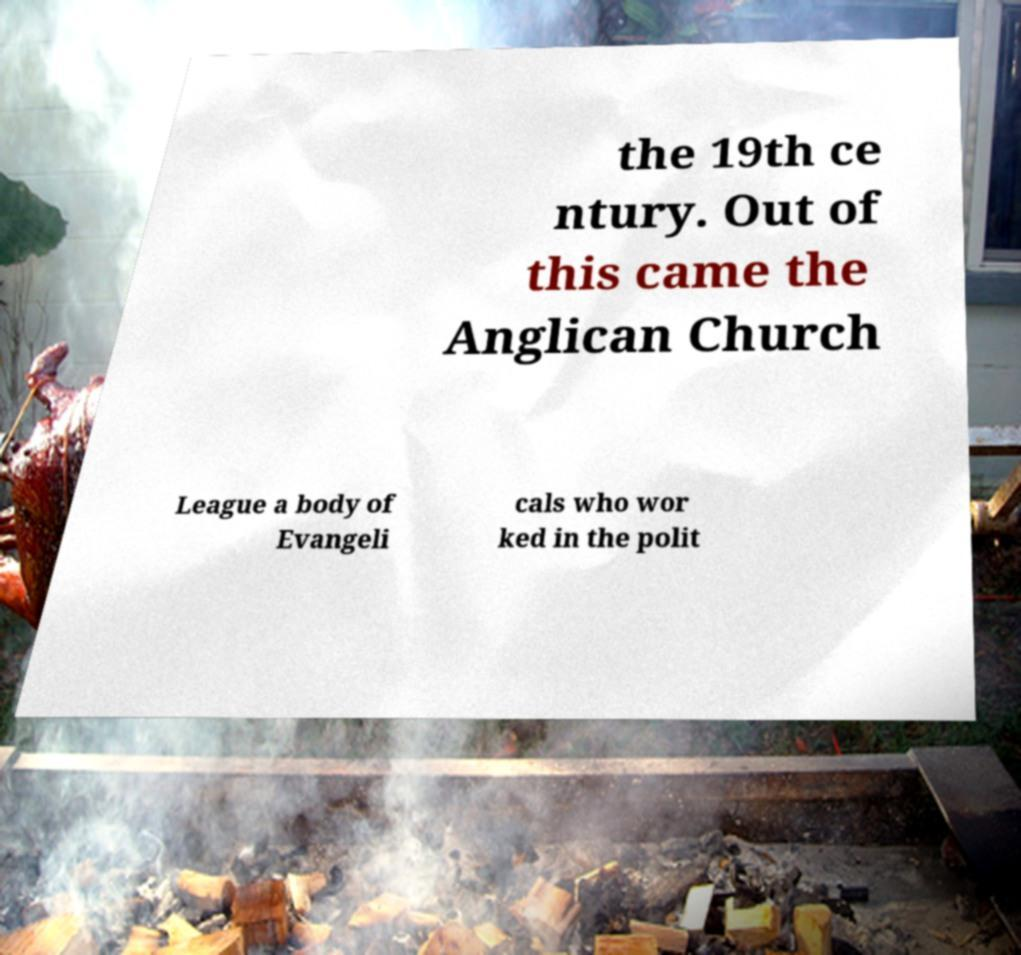Could you extract and type out the text from this image? the 19th ce ntury. Out of this came the Anglican Church League a body of Evangeli cals who wor ked in the polit 